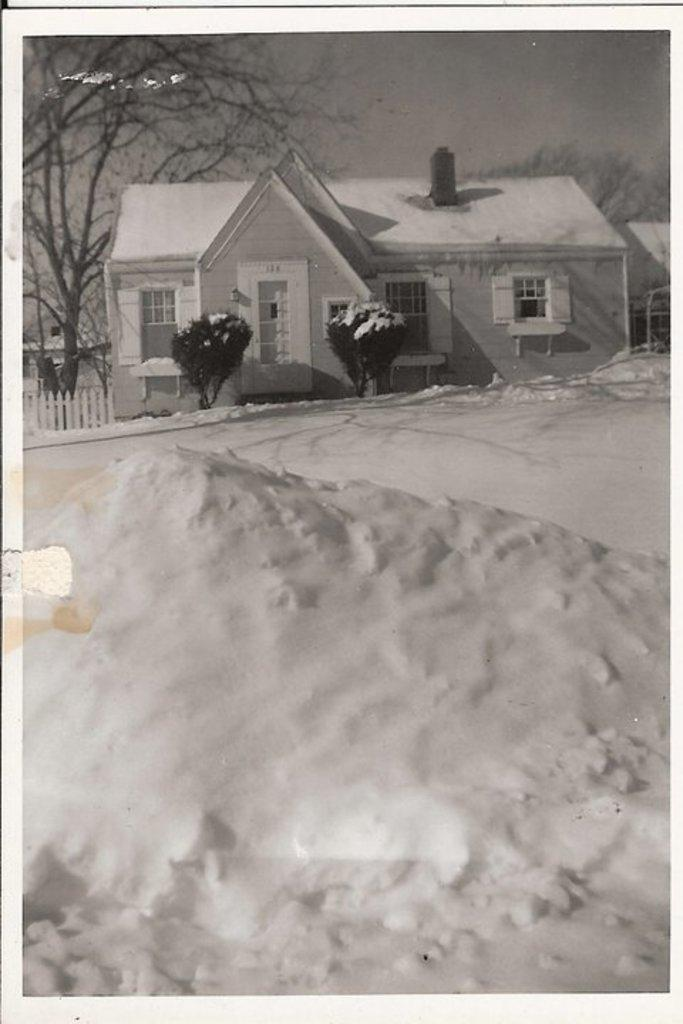What is the color scheme of the image? The image is black and white. What type of structure is visible in the image? There is a house with windows in the image. What type of vegetation can be seen in the image? There are plants and trees in the image. What is the condition of the land in the image? The land is covered with snow. What type of flower is blooming in the image? There are no flowers present in the image, as it is a black and white image with snow-covered land. 